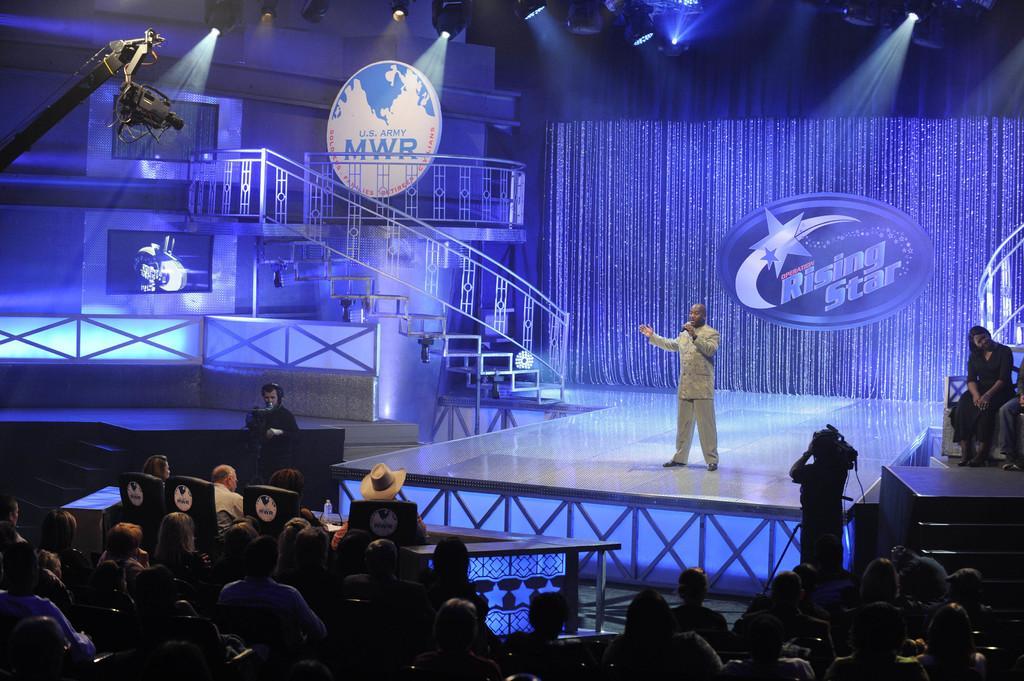Describe this image in one or two sentences. This picture shows few people seated on the chairs and we see a man standing and speaking with the help of a microphone and we see a man standing and holding a camera and recording. 